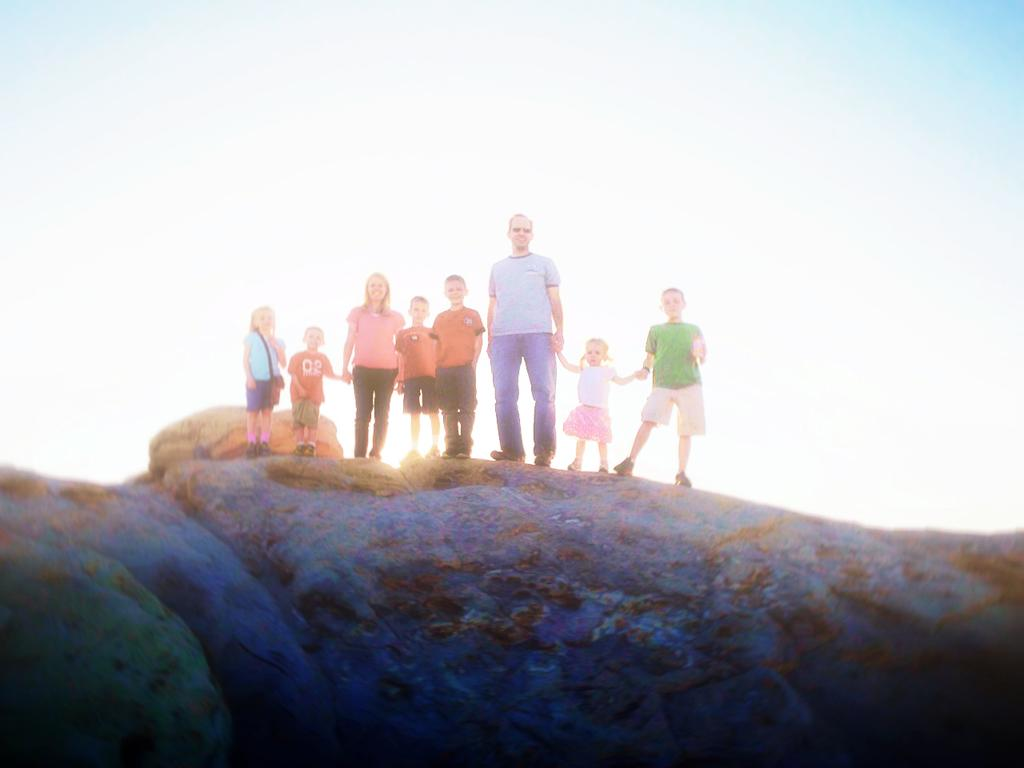What type of natural formation can be seen in the image? There are rocks in the image. What are the people in the image doing? People are standing on the rocks. What can be seen in the background of the image? The sky is visible in the background of the image. What type of tray can be seen in the image? There is no tray present in the image. Is there a door visible in the image? There is no door visible in the image. 